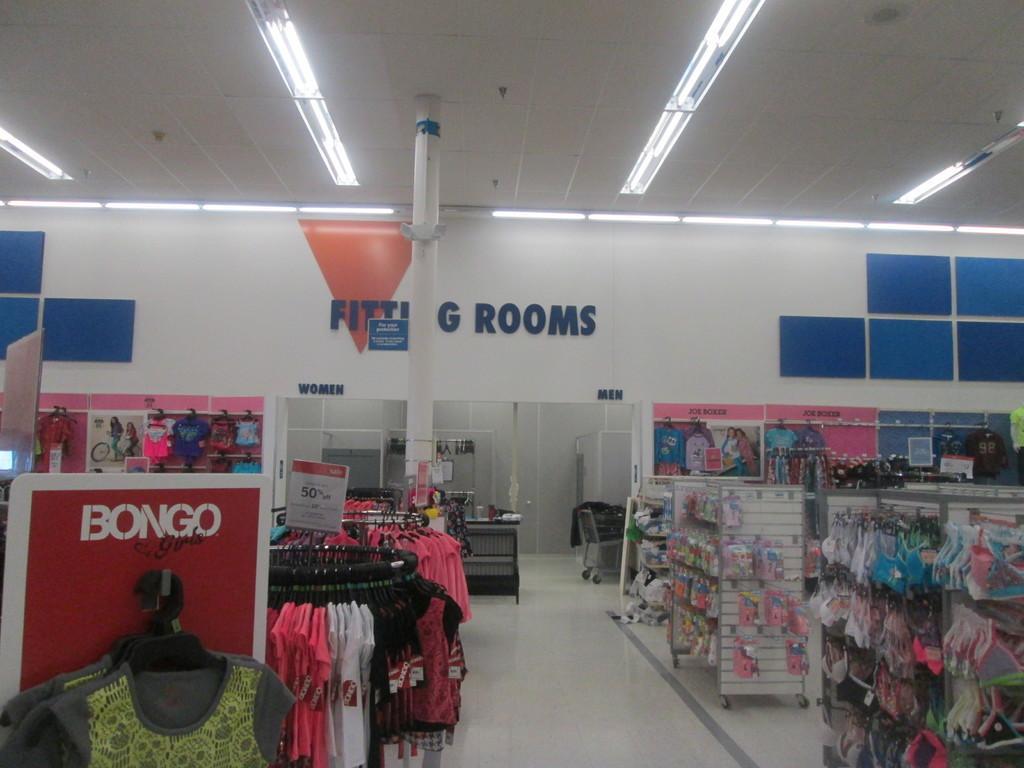Can you describe this image briefly? In this image we can see some clothes on the stands,there are boards with text on them, also we can see some objects on the racks, there are text on the wall, there is a trolley, there are lights, also we can see the roof. 